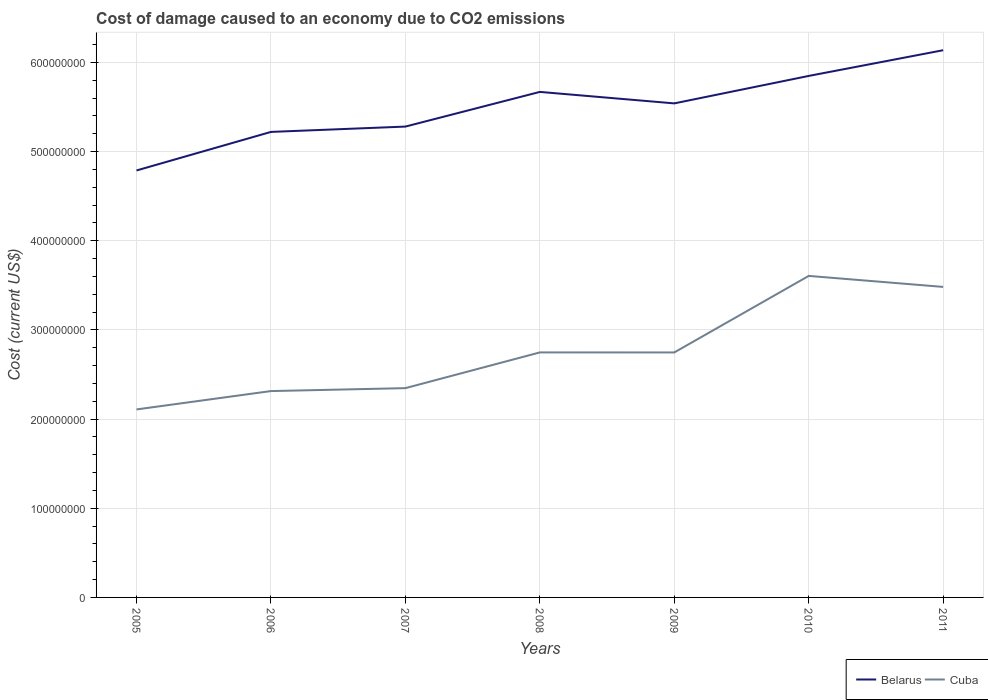How many different coloured lines are there?
Provide a short and direct response. 2. Is the number of lines equal to the number of legend labels?
Provide a succinct answer. Yes. Across all years, what is the maximum cost of damage caused due to CO2 emissisons in Cuba?
Provide a succinct answer. 2.11e+08. What is the total cost of damage caused due to CO2 emissisons in Belarus in the graph?
Your answer should be very brief. -4.68e+07. What is the difference between the highest and the second highest cost of damage caused due to CO2 emissisons in Cuba?
Your answer should be very brief. 1.50e+08. What is the difference between the highest and the lowest cost of damage caused due to CO2 emissisons in Belarus?
Make the answer very short. 4. How many years are there in the graph?
Your answer should be very brief. 7. Are the values on the major ticks of Y-axis written in scientific E-notation?
Ensure brevity in your answer.  No. Does the graph contain any zero values?
Your response must be concise. No. Does the graph contain grids?
Offer a terse response. Yes. How many legend labels are there?
Your answer should be compact. 2. How are the legend labels stacked?
Offer a terse response. Horizontal. What is the title of the graph?
Give a very brief answer. Cost of damage caused to an economy due to CO2 emissions. What is the label or title of the X-axis?
Your answer should be very brief. Years. What is the label or title of the Y-axis?
Keep it short and to the point. Cost (current US$). What is the Cost (current US$) of Belarus in 2005?
Provide a succinct answer. 4.79e+08. What is the Cost (current US$) of Cuba in 2005?
Your answer should be very brief. 2.11e+08. What is the Cost (current US$) in Belarus in 2006?
Give a very brief answer. 5.22e+08. What is the Cost (current US$) in Cuba in 2006?
Your answer should be very brief. 2.31e+08. What is the Cost (current US$) in Belarus in 2007?
Provide a succinct answer. 5.28e+08. What is the Cost (current US$) in Cuba in 2007?
Your response must be concise. 2.35e+08. What is the Cost (current US$) of Belarus in 2008?
Provide a short and direct response. 5.67e+08. What is the Cost (current US$) of Cuba in 2008?
Give a very brief answer. 2.75e+08. What is the Cost (current US$) in Belarus in 2009?
Your answer should be very brief. 5.54e+08. What is the Cost (current US$) of Cuba in 2009?
Keep it short and to the point. 2.75e+08. What is the Cost (current US$) in Belarus in 2010?
Make the answer very short. 5.85e+08. What is the Cost (current US$) in Cuba in 2010?
Offer a very short reply. 3.61e+08. What is the Cost (current US$) of Belarus in 2011?
Keep it short and to the point. 6.14e+08. What is the Cost (current US$) of Cuba in 2011?
Provide a succinct answer. 3.48e+08. Across all years, what is the maximum Cost (current US$) of Belarus?
Your response must be concise. 6.14e+08. Across all years, what is the maximum Cost (current US$) in Cuba?
Provide a succinct answer. 3.61e+08. Across all years, what is the minimum Cost (current US$) of Belarus?
Offer a terse response. 4.79e+08. Across all years, what is the minimum Cost (current US$) in Cuba?
Provide a short and direct response. 2.11e+08. What is the total Cost (current US$) in Belarus in the graph?
Offer a very short reply. 3.85e+09. What is the total Cost (current US$) of Cuba in the graph?
Offer a very short reply. 1.93e+09. What is the difference between the Cost (current US$) in Belarus in 2005 and that in 2006?
Provide a succinct answer. -4.32e+07. What is the difference between the Cost (current US$) in Cuba in 2005 and that in 2006?
Offer a very short reply. -2.06e+07. What is the difference between the Cost (current US$) in Belarus in 2005 and that in 2007?
Your response must be concise. -4.92e+07. What is the difference between the Cost (current US$) of Cuba in 2005 and that in 2007?
Provide a succinct answer. -2.39e+07. What is the difference between the Cost (current US$) in Belarus in 2005 and that in 2008?
Make the answer very short. -8.81e+07. What is the difference between the Cost (current US$) of Cuba in 2005 and that in 2008?
Keep it short and to the point. -6.39e+07. What is the difference between the Cost (current US$) of Belarus in 2005 and that in 2009?
Your response must be concise. -7.52e+07. What is the difference between the Cost (current US$) in Cuba in 2005 and that in 2009?
Ensure brevity in your answer.  -6.39e+07. What is the difference between the Cost (current US$) in Belarus in 2005 and that in 2010?
Offer a very short reply. -1.06e+08. What is the difference between the Cost (current US$) in Cuba in 2005 and that in 2010?
Offer a very short reply. -1.50e+08. What is the difference between the Cost (current US$) in Belarus in 2005 and that in 2011?
Ensure brevity in your answer.  -1.35e+08. What is the difference between the Cost (current US$) of Cuba in 2005 and that in 2011?
Provide a succinct answer. -1.37e+08. What is the difference between the Cost (current US$) of Belarus in 2006 and that in 2007?
Ensure brevity in your answer.  -5.97e+06. What is the difference between the Cost (current US$) in Cuba in 2006 and that in 2007?
Offer a very short reply. -3.29e+06. What is the difference between the Cost (current US$) in Belarus in 2006 and that in 2008?
Make the answer very short. -4.49e+07. What is the difference between the Cost (current US$) in Cuba in 2006 and that in 2008?
Your response must be concise. -4.33e+07. What is the difference between the Cost (current US$) in Belarus in 2006 and that in 2009?
Provide a succinct answer. -3.20e+07. What is the difference between the Cost (current US$) in Cuba in 2006 and that in 2009?
Provide a short and direct response. -4.33e+07. What is the difference between the Cost (current US$) of Belarus in 2006 and that in 2010?
Provide a succinct answer. -6.28e+07. What is the difference between the Cost (current US$) of Cuba in 2006 and that in 2010?
Provide a short and direct response. -1.29e+08. What is the difference between the Cost (current US$) in Belarus in 2006 and that in 2011?
Provide a succinct answer. -9.16e+07. What is the difference between the Cost (current US$) of Cuba in 2006 and that in 2011?
Your answer should be compact. -1.17e+08. What is the difference between the Cost (current US$) in Belarus in 2007 and that in 2008?
Your answer should be very brief. -3.89e+07. What is the difference between the Cost (current US$) of Cuba in 2007 and that in 2008?
Your response must be concise. -4.00e+07. What is the difference between the Cost (current US$) of Belarus in 2007 and that in 2009?
Make the answer very short. -2.60e+07. What is the difference between the Cost (current US$) in Cuba in 2007 and that in 2009?
Your answer should be very brief. -4.00e+07. What is the difference between the Cost (current US$) in Belarus in 2007 and that in 2010?
Offer a very short reply. -5.68e+07. What is the difference between the Cost (current US$) of Cuba in 2007 and that in 2010?
Your answer should be compact. -1.26e+08. What is the difference between the Cost (current US$) of Belarus in 2007 and that in 2011?
Offer a very short reply. -8.56e+07. What is the difference between the Cost (current US$) of Cuba in 2007 and that in 2011?
Provide a succinct answer. -1.14e+08. What is the difference between the Cost (current US$) in Belarus in 2008 and that in 2009?
Offer a very short reply. 1.29e+07. What is the difference between the Cost (current US$) in Cuba in 2008 and that in 2009?
Offer a terse response. 2.36e+04. What is the difference between the Cost (current US$) of Belarus in 2008 and that in 2010?
Offer a terse response. -1.79e+07. What is the difference between the Cost (current US$) in Cuba in 2008 and that in 2010?
Provide a succinct answer. -8.58e+07. What is the difference between the Cost (current US$) in Belarus in 2008 and that in 2011?
Your response must be concise. -4.68e+07. What is the difference between the Cost (current US$) in Cuba in 2008 and that in 2011?
Your answer should be compact. -7.35e+07. What is the difference between the Cost (current US$) in Belarus in 2009 and that in 2010?
Provide a succinct answer. -3.08e+07. What is the difference between the Cost (current US$) in Cuba in 2009 and that in 2010?
Offer a terse response. -8.58e+07. What is the difference between the Cost (current US$) of Belarus in 2009 and that in 2011?
Your answer should be very brief. -5.96e+07. What is the difference between the Cost (current US$) of Cuba in 2009 and that in 2011?
Your response must be concise. -7.35e+07. What is the difference between the Cost (current US$) of Belarus in 2010 and that in 2011?
Give a very brief answer. -2.88e+07. What is the difference between the Cost (current US$) of Cuba in 2010 and that in 2011?
Give a very brief answer. 1.23e+07. What is the difference between the Cost (current US$) of Belarus in 2005 and the Cost (current US$) of Cuba in 2006?
Provide a short and direct response. 2.47e+08. What is the difference between the Cost (current US$) of Belarus in 2005 and the Cost (current US$) of Cuba in 2007?
Keep it short and to the point. 2.44e+08. What is the difference between the Cost (current US$) of Belarus in 2005 and the Cost (current US$) of Cuba in 2008?
Your answer should be very brief. 2.04e+08. What is the difference between the Cost (current US$) in Belarus in 2005 and the Cost (current US$) in Cuba in 2009?
Make the answer very short. 2.04e+08. What is the difference between the Cost (current US$) in Belarus in 2005 and the Cost (current US$) in Cuba in 2010?
Keep it short and to the point. 1.18e+08. What is the difference between the Cost (current US$) in Belarus in 2005 and the Cost (current US$) in Cuba in 2011?
Your response must be concise. 1.31e+08. What is the difference between the Cost (current US$) of Belarus in 2006 and the Cost (current US$) of Cuba in 2007?
Your answer should be compact. 2.87e+08. What is the difference between the Cost (current US$) of Belarus in 2006 and the Cost (current US$) of Cuba in 2008?
Provide a succinct answer. 2.47e+08. What is the difference between the Cost (current US$) of Belarus in 2006 and the Cost (current US$) of Cuba in 2009?
Ensure brevity in your answer.  2.47e+08. What is the difference between the Cost (current US$) in Belarus in 2006 and the Cost (current US$) in Cuba in 2010?
Give a very brief answer. 1.61e+08. What is the difference between the Cost (current US$) of Belarus in 2006 and the Cost (current US$) of Cuba in 2011?
Offer a very short reply. 1.74e+08. What is the difference between the Cost (current US$) in Belarus in 2007 and the Cost (current US$) in Cuba in 2008?
Ensure brevity in your answer.  2.53e+08. What is the difference between the Cost (current US$) of Belarus in 2007 and the Cost (current US$) of Cuba in 2009?
Provide a short and direct response. 2.53e+08. What is the difference between the Cost (current US$) in Belarus in 2007 and the Cost (current US$) in Cuba in 2010?
Provide a succinct answer. 1.67e+08. What is the difference between the Cost (current US$) in Belarus in 2007 and the Cost (current US$) in Cuba in 2011?
Your answer should be very brief. 1.80e+08. What is the difference between the Cost (current US$) of Belarus in 2008 and the Cost (current US$) of Cuba in 2009?
Offer a terse response. 2.92e+08. What is the difference between the Cost (current US$) of Belarus in 2008 and the Cost (current US$) of Cuba in 2010?
Keep it short and to the point. 2.06e+08. What is the difference between the Cost (current US$) in Belarus in 2008 and the Cost (current US$) in Cuba in 2011?
Make the answer very short. 2.19e+08. What is the difference between the Cost (current US$) of Belarus in 2009 and the Cost (current US$) of Cuba in 2010?
Your answer should be compact. 1.93e+08. What is the difference between the Cost (current US$) of Belarus in 2009 and the Cost (current US$) of Cuba in 2011?
Your answer should be compact. 2.06e+08. What is the difference between the Cost (current US$) in Belarus in 2010 and the Cost (current US$) in Cuba in 2011?
Provide a succinct answer. 2.37e+08. What is the average Cost (current US$) of Belarus per year?
Offer a terse response. 5.50e+08. What is the average Cost (current US$) in Cuba per year?
Your response must be concise. 2.76e+08. In the year 2005, what is the difference between the Cost (current US$) in Belarus and Cost (current US$) in Cuba?
Ensure brevity in your answer.  2.68e+08. In the year 2006, what is the difference between the Cost (current US$) of Belarus and Cost (current US$) of Cuba?
Make the answer very short. 2.91e+08. In the year 2007, what is the difference between the Cost (current US$) in Belarus and Cost (current US$) in Cuba?
Provide a succinct answer. 2.93e+08. In the year 2008, what is the difference between the Cost (current US$) of Belarus and Cost (current US$) of Cuba?
Keep it short and to the point. 2.92e+08. In the year 2009, what is the difference between the Cost (current US$) of Belarus and Cost (current US$) of Cuba?
Keep it short and to the point. 2.79e+08. In the year 2010, what is the difference between the Cost (current US$) in Belarus and Cost (current US$) in Cuba?
Offer a very short reply. 2.24e+08. In the year 2011, what is the difference between the Cost (current US$) in Belarus and Cost (current US$) in Cuba?
Ensure brevity in your answer.  2.65e+08. What is the ratio of the Cost (current US$) of Belarus in 2005 to that in 2006?
Your response must be concise. 0.92. What is the ratio of the Cost (current US$) in Cuba in 2005 to that in 2006?
Your response must be concise. 0.91. What is the ratio of the Cost (current US$) of Belarus in 2005 to that in 2007?
Provide a short and direct response. 0.91. What is the ratio of the Cost (current US$) of Cuba in 2005 to that in 2007?
Make the answer very short. 0.9. What is the ratio of the Cost (current US$) in Belarus in 2005 to that in 2008?
Make the answer very short. 0.84. What is the ratio of the Cost (current US$) in Cuba in 2005 to that in 2008?
Make the answer very short. 0.77. What is the ratio of the Cost (current US$) in Belarus in 2005 to that in 2009?
Offer a terse response. 0.86. What is the ratio of the Cost (current US$) of Cuba in 2005 to that in 2009?
Provide a succinct answer. 0.77. What is the ratio of the Cost (current US$) of Belarus in 2005 to that in 2010?
Your answer should be very brief. 0.82. What is the ratio of the Cost (current US$) of Cuba in 2005 to that in 2010?
Give a very brief answer. 0.58. What is the ratio of the Cost (current US$) of Belarus in 2005 to that in 2011?
Your answer should be compact. 0.78. What is the ratio of the Cost (current US$) of Cuba in 2005 to that in 2011?
Keep it short and to the point. 0.61. What is the ratio of the Cost (current US$) in Belarus in 2006 to that in 2007?
Keep it short and to the point. 0.99. What is the ratio of the Cost (current US$) in Cuba in 2006 to that in 2007?
Provide a succinct answer. 0.99. What is the ratio of the Cost (current US$) of Belarus in 2006 to that in 2008?
Your answer should be very brief. 0.92. What is the ratio of the Cost (current US$) of Cuba in 2006 to that in 2008?
Provide a short and direct response. 0.84. What is the ratio of the Cost (current US$) in Belarus in 2006 to that in 2009?
Your answer should be compact. 0.94. What is the ratio of the Cost (current US$) in Cuba in 2006 to that in 2009?
Offer a terse response. 0.84. What is the ratio of the Cost (current US$) in Belarus in 2006 to that in 2010?
Give a very brief answer. 0.89. What is the ratio of the Cost (current US$) in Cuba in 2006 to that in 2010?
Provide a succinct answer. 0.64. What is the ratio of the Cost (current US$) of Belarus in 2006 to that in 2011?
Ensure brevity in your answer.  0.85. What is the ratio of the Cost (current US$) of Cuba in 2006 to that in 2011?
Offer a very short reply. 0.66. What is the ratio of the Cost (current US$) in Belarus in 2007 to that in 2008?
Provide a succinct answer. 0.93. What is the ratio of the Cost (current US$) in Cuba in 2007 to that in 2008?
Provide a succinct answer. 0.85. What is the ratio of the Cost (current US$) of Belarus in 2007 to that in 2009?
Your response must be concise. 0.95. What is the ratio of the Cost (current US$) of Cuba in 2007 to that in 2009?
Offer a terse response. 0.85. What is the ratio of the Cost (current US$) of Belarus in 2007 to that in 2010?
Provide a succinct answer. 0.9. What is the ratio of the Cost (current US$) of Cuba in 2007 to that in 2010?
Ensure brevity in your answer.  0.65. What is the ratio of the Cost (current US$) in Belarus in 2007 to that in 2011?
Provide a short and direct response. 0.86. What is the ratio of the Cost (current US$) in Cuba in 2007 to that in 2011?
Keep it short and to the point. 0.67. What is the ratio of the Cost (current US$) in Belarus in 2008 to that in 2009?
Your response must be concise. 1.02. What is the ratio of the Cost (current US$) of Belarus in 2008 to that in 2010?
Make the answer very short. 0.97. What is the ratio of the Cost (current US$) of Cuba in 2008 to that in 2010?
Your answer should be very brief. 0.76. What is the ratio of the Cost (current US$) in Belarus in 2008 to that in 2011?
Offer a terse response. 0.92. What is the ratio of the Cost (current US$) of Cuba in 2008 to that in 2011?
Ensure brevity in your answer.  0.79. What is the ratio of the Cost (current US$) in Belarus in 2009 to that in 2010?
Offer a terse response. 0.95. What is the ratio of the Cost (current US$) of Cuba in 2009 to that in 2010?
Provide a succinct answer. 0.76. What is the ratio of the Cost (current US$) in Belarus in 2009 to that in 2011?
Keep it short and to the point. 0.9. What is the ratio of the Cost (current US$) in Cuba in 2009 to that in 2011?
Your response must be concise. 0.79. What is the ratio of the Cost (current US$) in Belarus in 2010 to that in 2011?
Keep it short and to the point. 0.95. What is the ratio of the Cost (current US$) of Cuba in 2010 to that in 2011?
Ensure brevity in your answer.  1.04. What is the difference between the highest and the second highest Cost (current US$) of Belarus?
Offer a very short reply. 2.88e+07. What is the difference between the highest and the second highest Cost (current US$) in Cuba?
Keep it short and to the point. 1.23e+07. What is the difference between the highest and the lowest Cost (current US$) of Belarus?
Give a very brief answer. 1.35e+08. What is the difference between the highest and the lowest Cost (current US$) of Cuba?
Ensure brevity in your answer.  1.50e+08. 